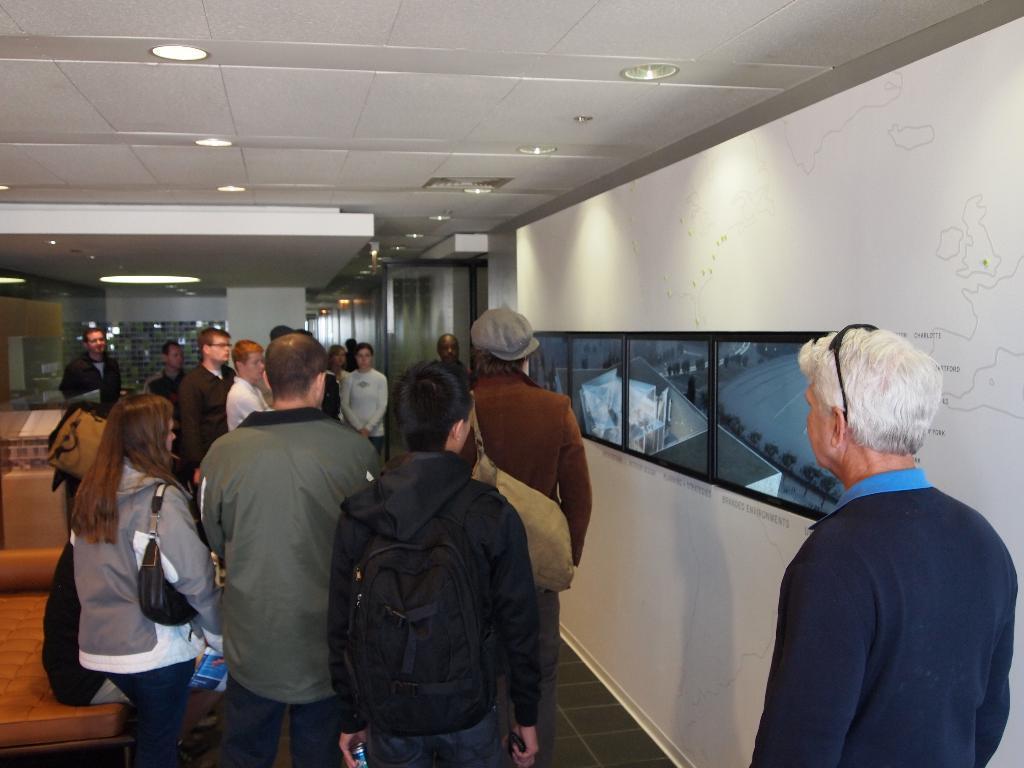How would you summarize this image in a sentence or two? In the image few people are standing and watching. Behind them there is a wall, on the wall there are some screens. Top of the image there are some lights and roof. Bottom left side of the image there is a couch. 